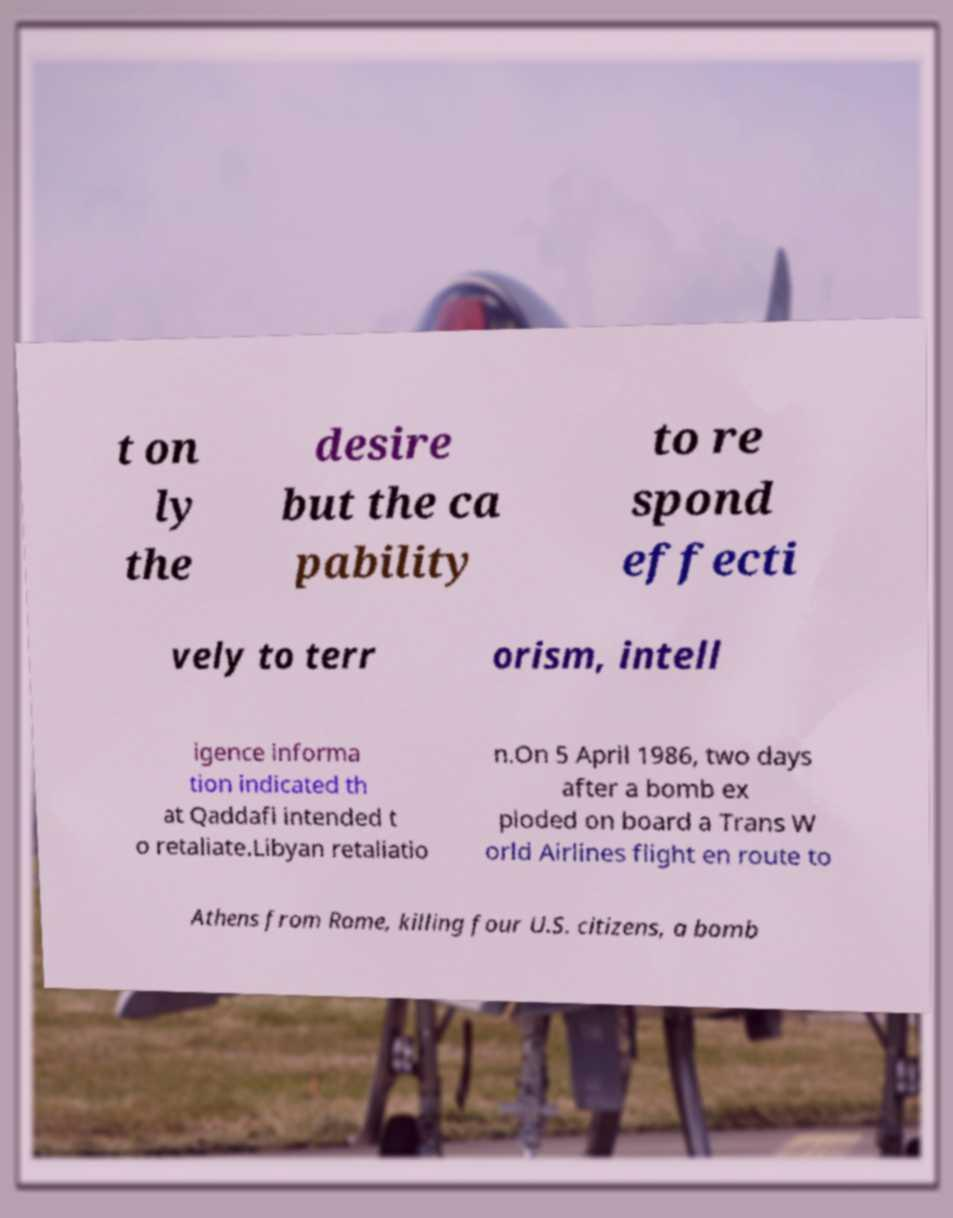For documentation purposes, I need the text within this image transcribed. Could you provide that? t on ly the desire but the ca pability to re spond effecti vely to terr orism, intell igence informa tion indicated th at Qaddafi intended t o retaliate.Libyan retaliatio n.On 5 April 1986, two days after a bomb ex ploded on board a Trans W orld Airlines flight en route to Athens from Rome, killing four U.S. citizens, a bomb 